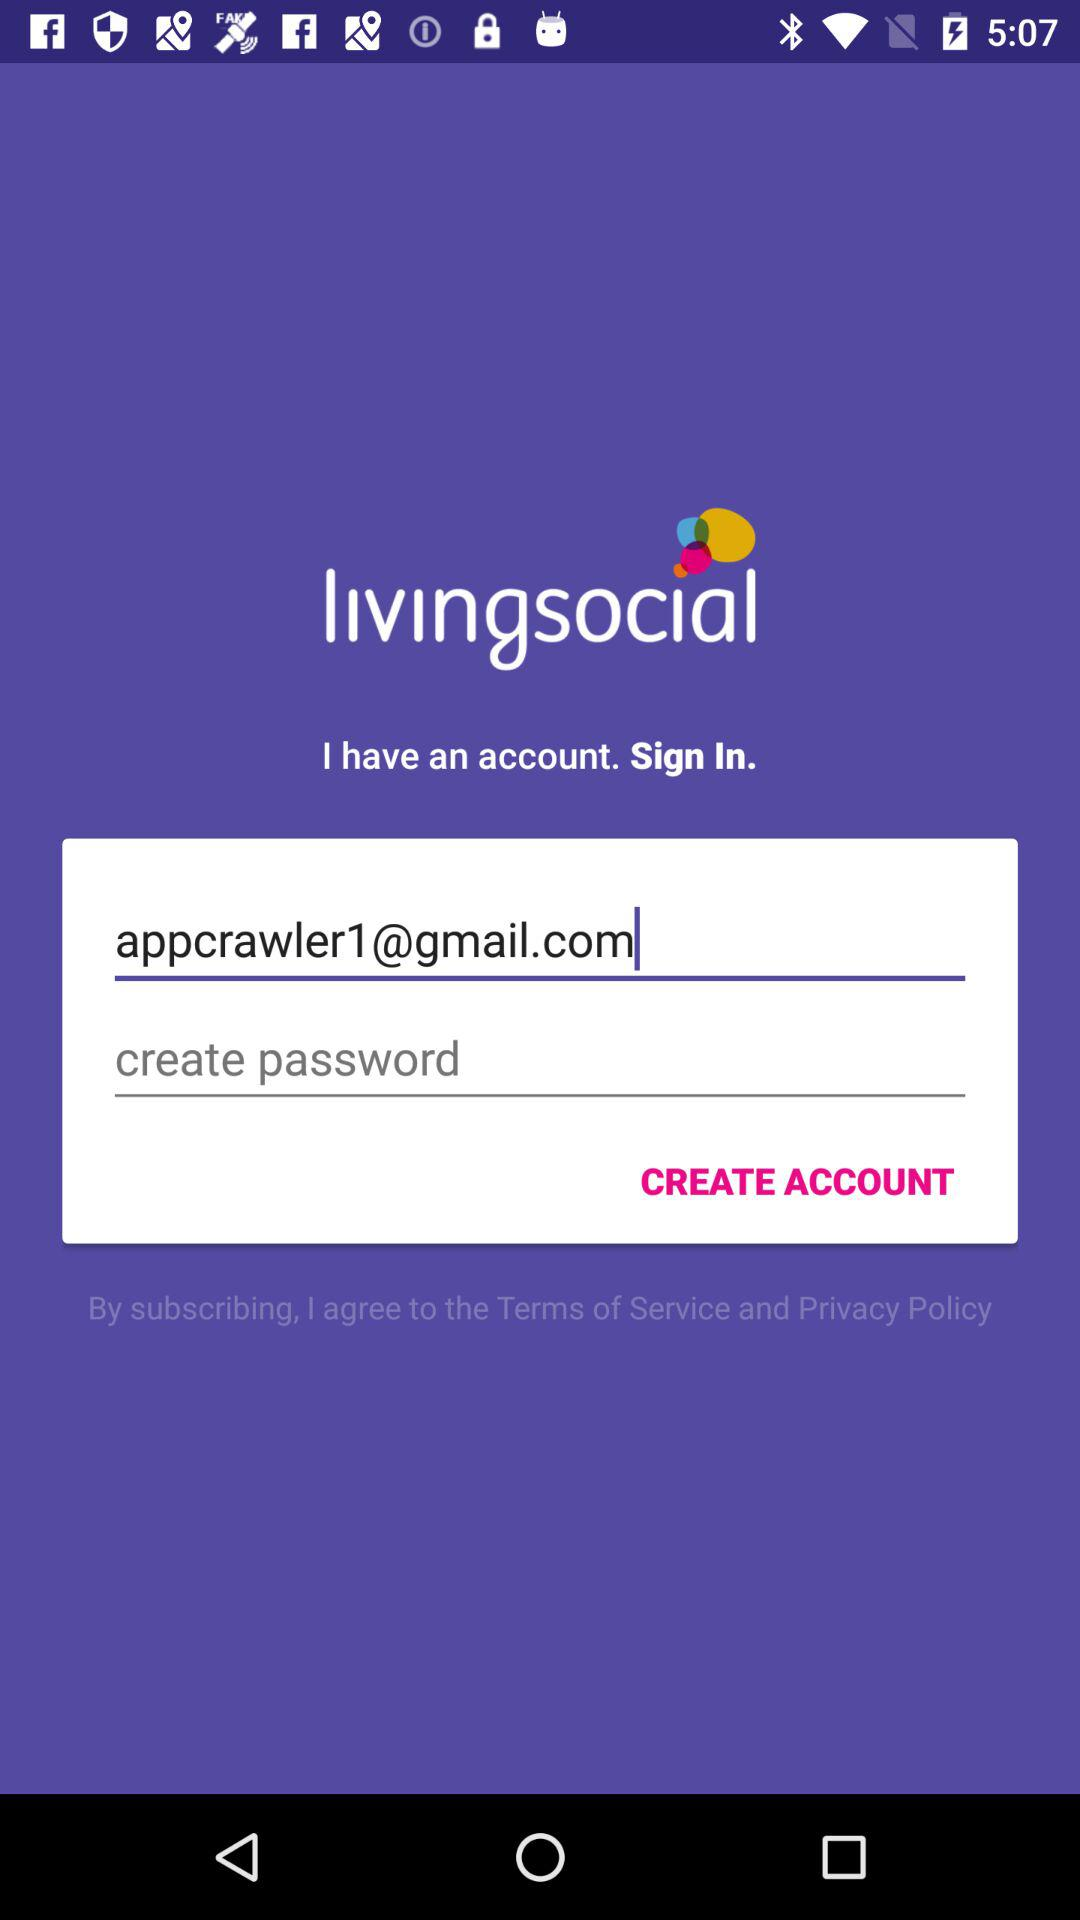What is the email address? The email address is appcrawler1@gmail.com. 